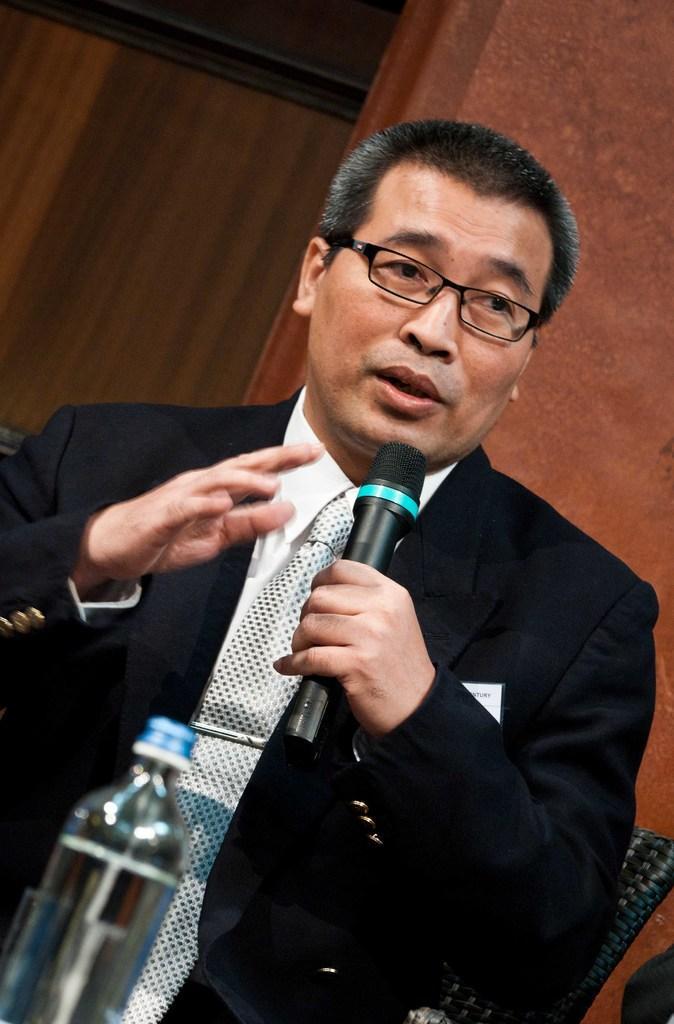In one or two sentences, can you explain what this image depicts? In this picture a black coat guy is talking with a mic in his hand and there is a water bottle on top of the table. 